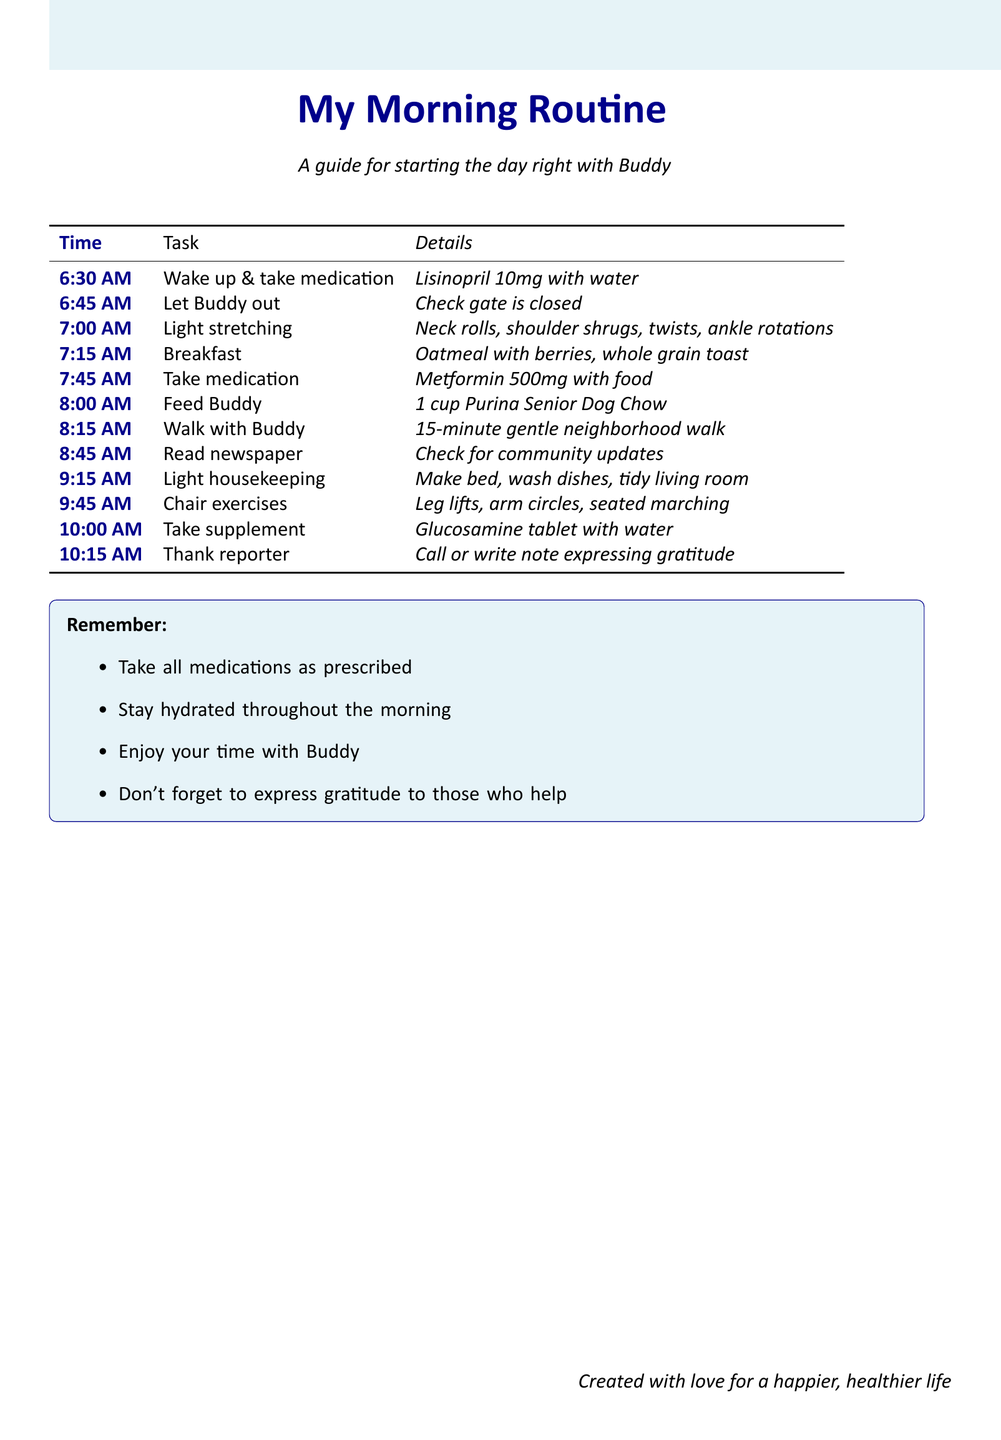What time do I take my blood pressure medication? The document states that blood pressure medication (Lisinopril) should be taken at 6:30 AM.
Answer: 6:30 AM What exercise starts my morning routine? The first exercise listed in the routine is light stretching exercises at 7:00 AM.
Answer: Light stretching exercises How long is the walk with Buddy? The document indicates that the walk with Buddy lasts for 15 minutes.
Answer: 15 minutes What medication do I take after breakfast? The diabetes medication (Metformin) is taken at 7:45 AM, which is after breakfast preparation.
Answer: Metformin What should I express gratitude for? The document highlights the importance of thanking the reporter who helped in finding Buddy.
Answer: Help in finding Buddy How many repetitions do I do for shoulder shrugs? The checklist details 10 repetitions for shoulder shrugs during the light stretching exercises.
Answer: 10 repetitions What should I feed Buddy? According to the morning routine checklist, Buddy should be fed 1 cup of Purina Senior Dog Chow.
Answer: 1 cup of Purina Senior Dog Chow At what time do I do chair exercises? The routine specifies that chair exercises are performed at 9:45 AM.
Answer: 9:45 AM What is a reminder included in the document? One reminder is to take all medications as prescribed.
Answer: Take all medications as prescribed 